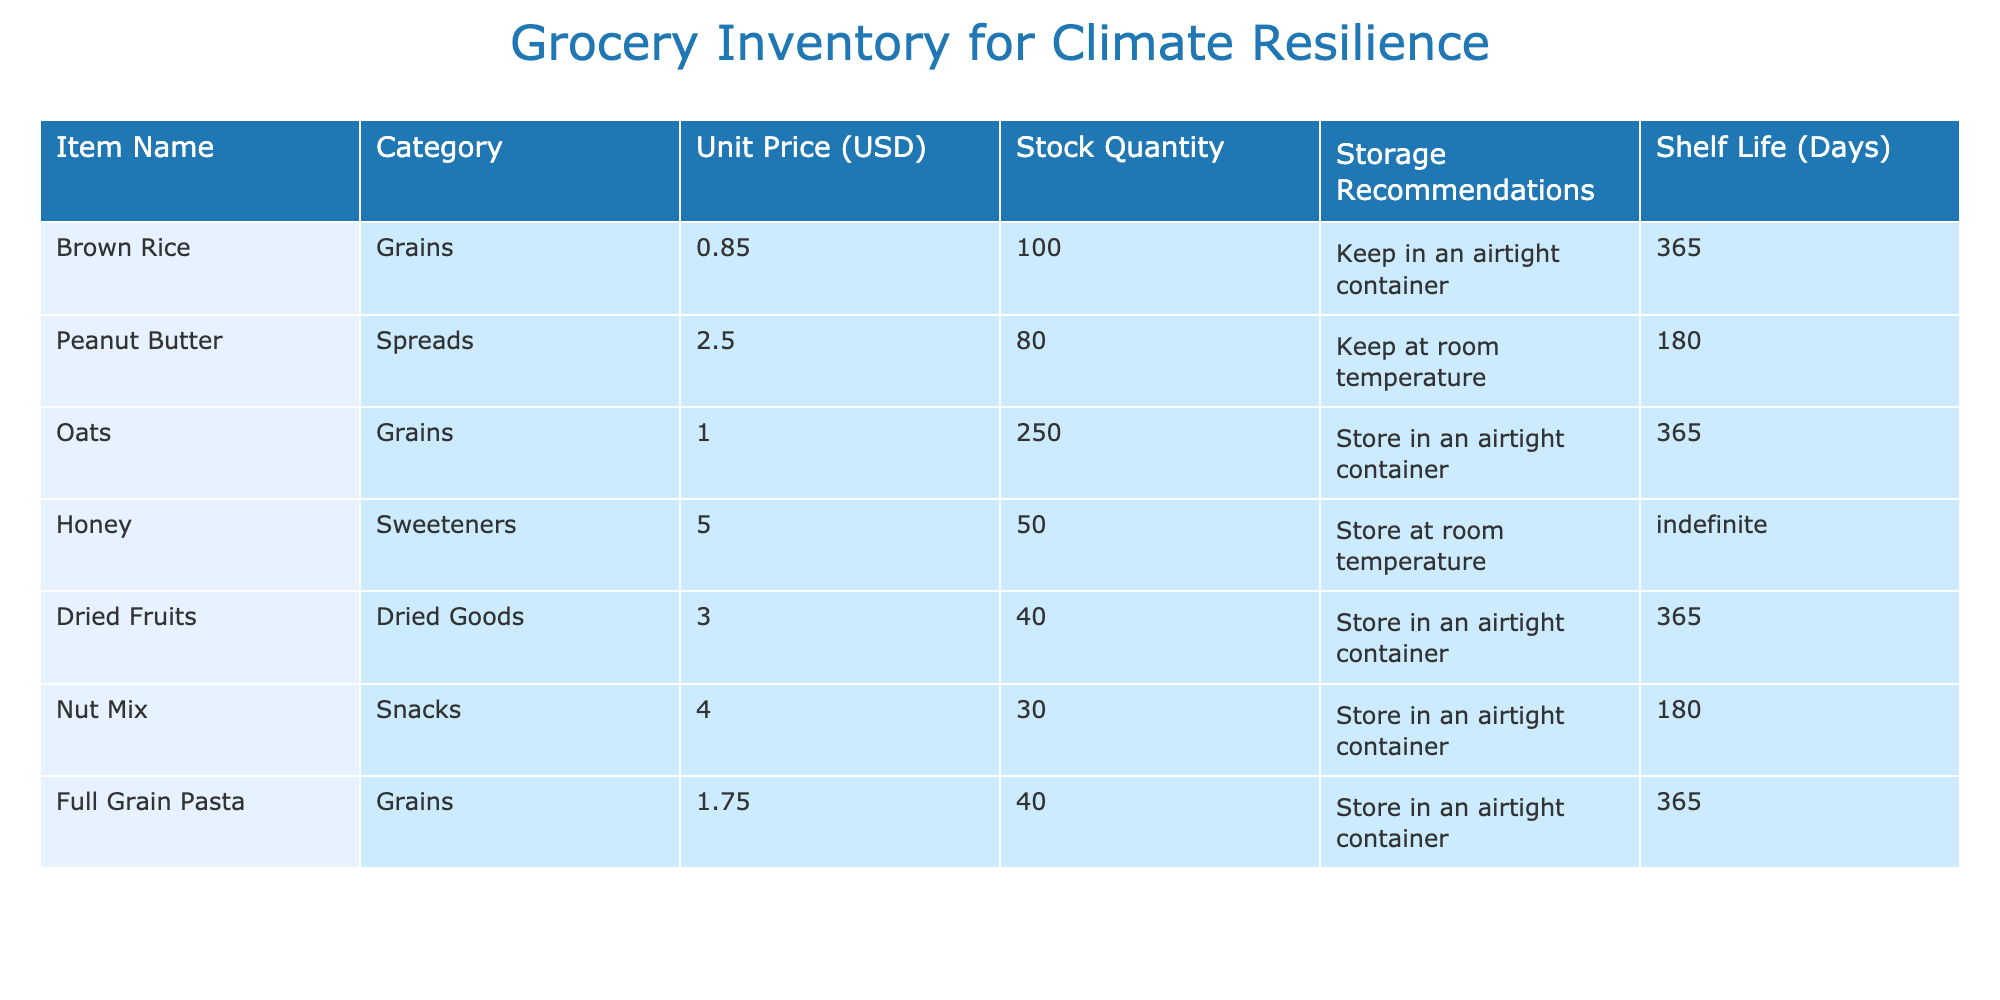What is the stock quantity of Honey? Looking at the table, we can find the row for Honey. The stock quantity field indicates that there are 50 units available.
Answer: 50 What is the unit price of Dried Fruits? Referring to the table, we locate the Dried Fruits row, which shows a unit price of 3.00 USD.
Answer: 3.00 Which item has the longest shelf life? To find the item with the longest shelf life, we review the shelf life values. Honey has an indefinite shelf life, while all others have a maximum of 365 days.
Answer: Honey Are there more or fewer units of Oats than Full Grain Pasta? First, we look at the stock quantities: Oats has 250 units, while Full Grain Pasta has 40 units. Since 250 is greater than 40, there are more units of Oats than Full Grain Pasta.
Answer: More What is the total stock quantity of Grains? We identify the items in the Grains category: Brown Rice (100), Oats (250), and Full Grain Pasta (40). Adding these gives 100 + 250 + 40 = 390.
Answer: 390 Is the unit price of Nut Mix greater than that of Peanut Butter? The unit price of Nut Mix is 4.00 USD, and for Peanut Butter, it is 2.50 USD. Since 4.00 is greater than 2.50, the statement is true.
Answer: Yes What would be the average unit price of all the items listed? We calculate the average unit price by first adding all unit prices: (0.85 + 2.50 + 1.00 + 5.00 + 3.00 + 4.00 + 1.75) = 18.10. The total number of items is 7, so the average is 18.10 / 7 = 2.58.
Answer: 2.58 Which item has the highest unit price, and what is that price? By reviewing the unit prices, we see that Honey has the highest price at 5.00 USD. Thus, the item with the highest price is Honey.
Answer: Honey, 5.00 How many items need to be stored in an airtight container? From the table, we check the storage recommendations. Brown Rice, Oats, Dried Fruits, Full Grain Pasta, and Nut Mix all require airtight containers, totaling 5 items.
Answer: 5 Can Dried Fruits be stored at room temperature? The storage recommendation for Dried Fruits explicitly states it should be stored in an airtight container, not at room temperature. Therefore, this statement is false.
Answer: No 